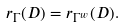Convert formula to latex. <formula><loc_0><loc_0><loc_500><loc_500>r _ { \Gamma } ( D ) = r _ { \Gamma ^ { w } } ( D ) .</formula> 